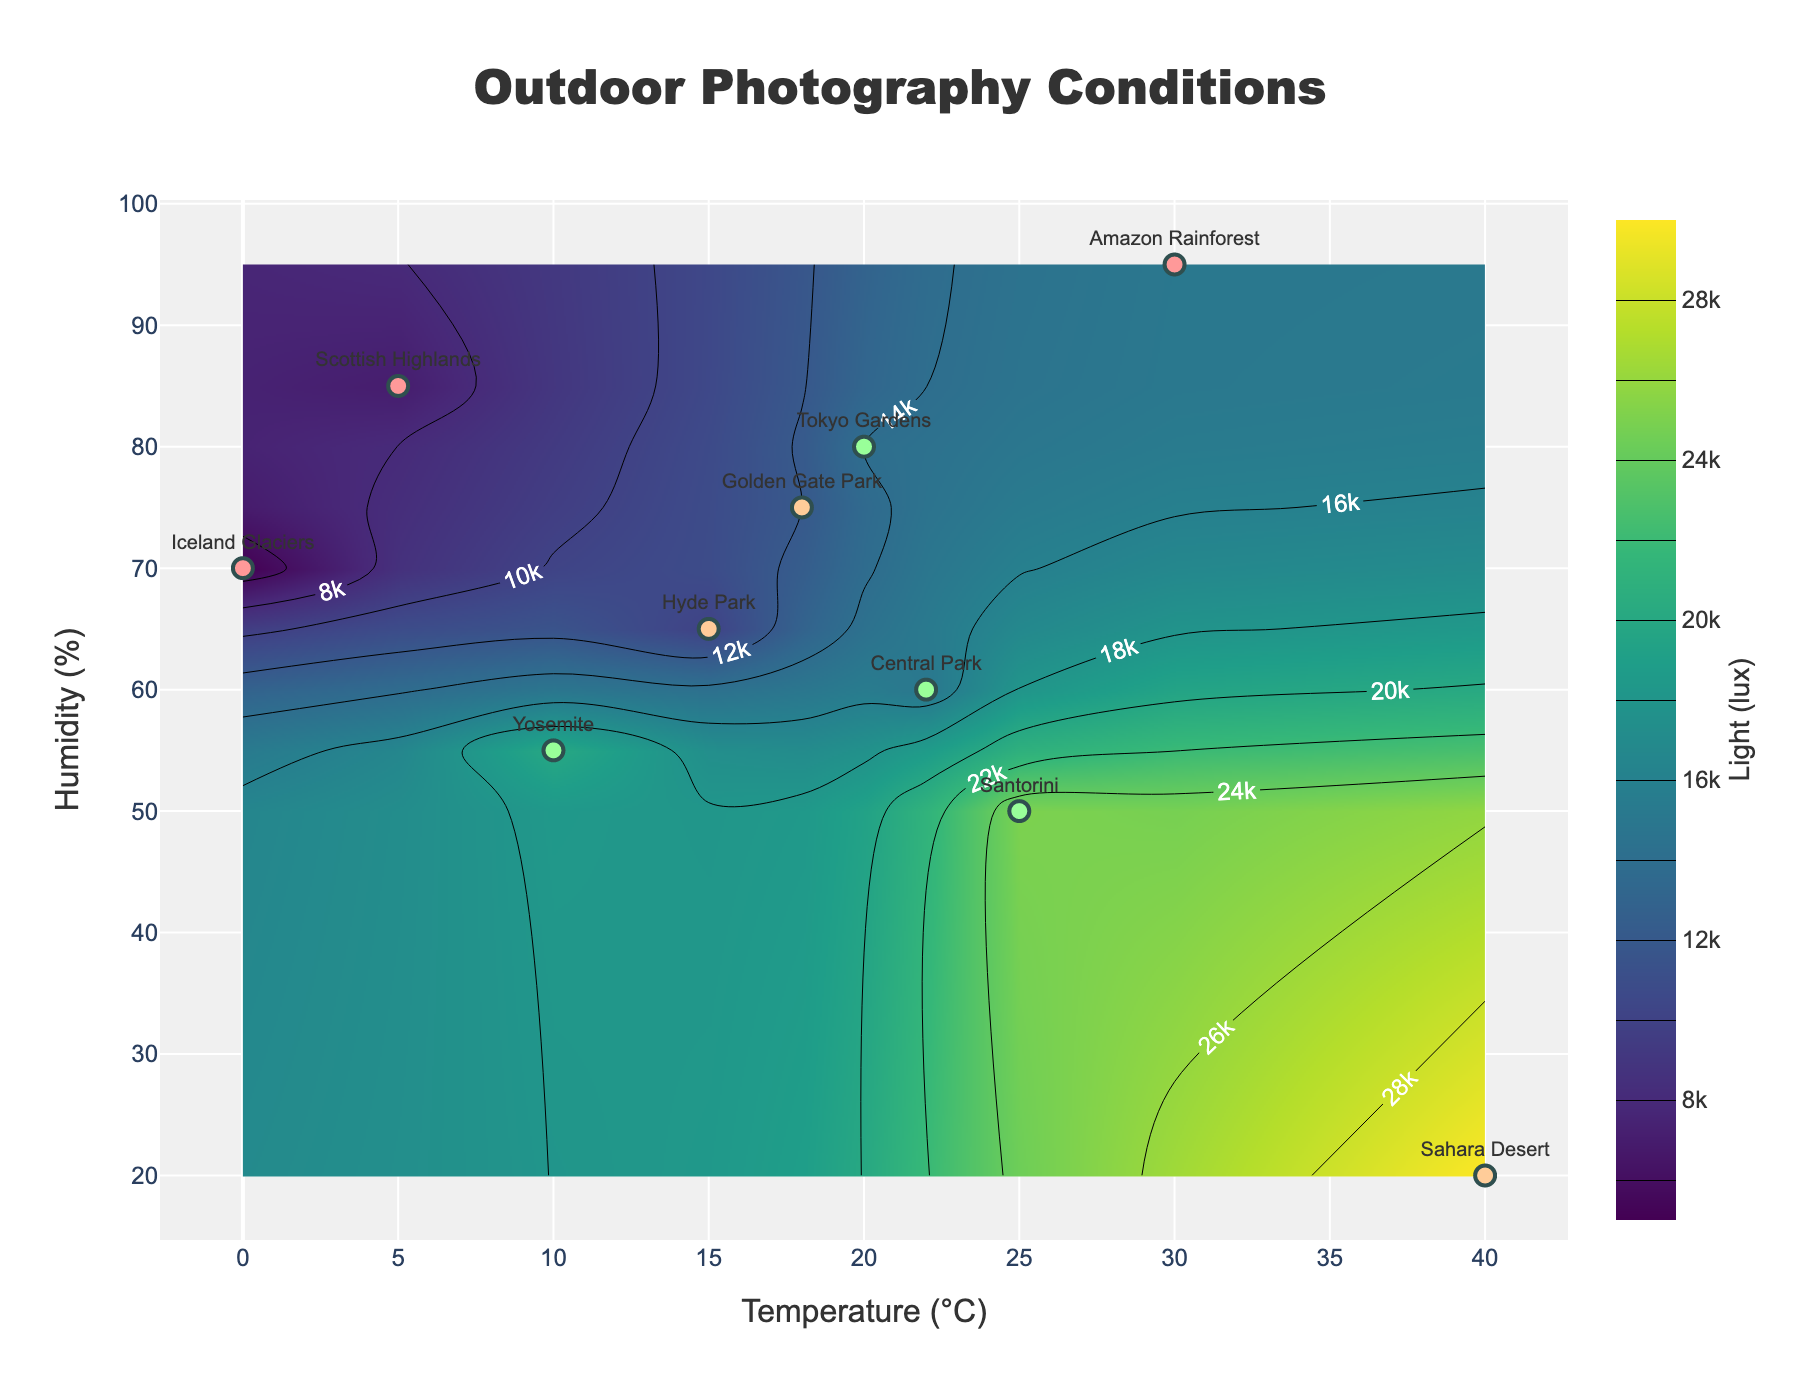What is the title of the plot? The title is typically the text at the top of the figure. In this case, it's clearly shown as "Outdoor Photography Conditions".
Answer: Outdoor Photography Conditions What are the axes titles on this contour plot? The x-axis title is "Temperature (°C)" and the y-axis title is "Humidity (%)". These titles are located along the graticules of the plot.
Answer: x-axis: Temperature (°C), y-axis: Humidity (%) How many locations have the highest "Suitability” for outdoor photography? Looking at the markers and their corresponding labels, the colors indicate the suitability levels. By counting the green markers (representing 'High'), we find there are 4 locations: Central Park, Yosemite, Santorini, and Tokyo Gardens.
Answer: 4 Which location has the highest temperature? Checking the data points along the x-axis for the highest value, the location with the highest temperature of 40°C is Sahara Desert.
Answer: Sahara Desert Which locations are classified as having 'Low' suitability for outdoor photography? Looking at the markers with red colors (indicative of 'Low' suitability), the locations are Scottish Highlands, Amazon Rainforest, and Iceland Glaciers.
Answer: Scottish Highlands, Amazon Rainforest, Iceland Glaciers Between what ranges does "Light (lux)" typically fall for ‘Medium’ suitability locations? Observing the color of markers that indicate ‘Medium’ suitability and referencing the color bar, Sahara Desert stands out with 30000 lux, Golden Gate Park with 12000 lux, and Hyde Park with 10000 lux. The light ranges from 10000 lux to 30000 lux for Medium suitability.
Answer: 10000 lux to 30000 lux Which location offers a good balance of moderate temperature and high suitability for photography? From the 'High' suitability locations (green markers), balancing criteria at moderate temperatures include: Central Park (22°C) and Tokyo Gardens (20°C).
Answer: Central Park, Tokyo Gardens Is there a location with a temperature under 10°C and low suitability indicated? Look for x-values below 10°C and red markers (low suitability). Scottish Highlands (5°C, Low) and Iceland Glaciers (0°C, Low) fit the criteria.
Answer: Scottish Highlands, Iceland Glaciers What is the humidity range that supports high outdoor photography suitability? Reviewing the green markers and matching y-values (humidity), we get 50% for Santorini and 55-60% for Central Park and Yosemite with Tokyo Gardens at 80%. The humidity range spans 50% to 80% for high suitability.
Answer: 50% to 80% How does the light intensity correlate with high suitability? Observing high suitability locations on the figure and the displayed light intensities in the color bar, Central Park and Tokyo Gardens have light intensities around 15000 lux, Yosemite close to 20000 lux, and Santorini around 25000 lux. Generally, high suitability corresponds with light intensities between 15000 to 25000 lux.
Answer: 15000 to 25000 lux 